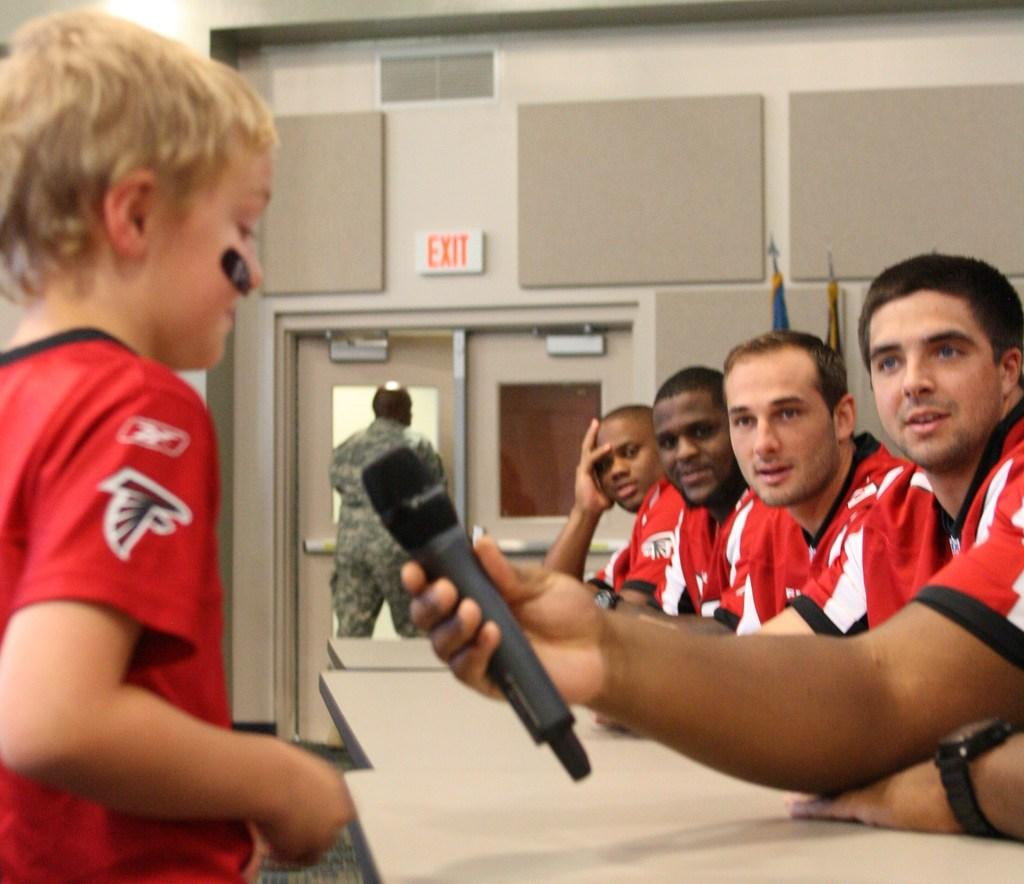<image>
Summarize the visual content of the image. Several men in red jerseys speak to a child, while there is an EXIT sign in the background. 